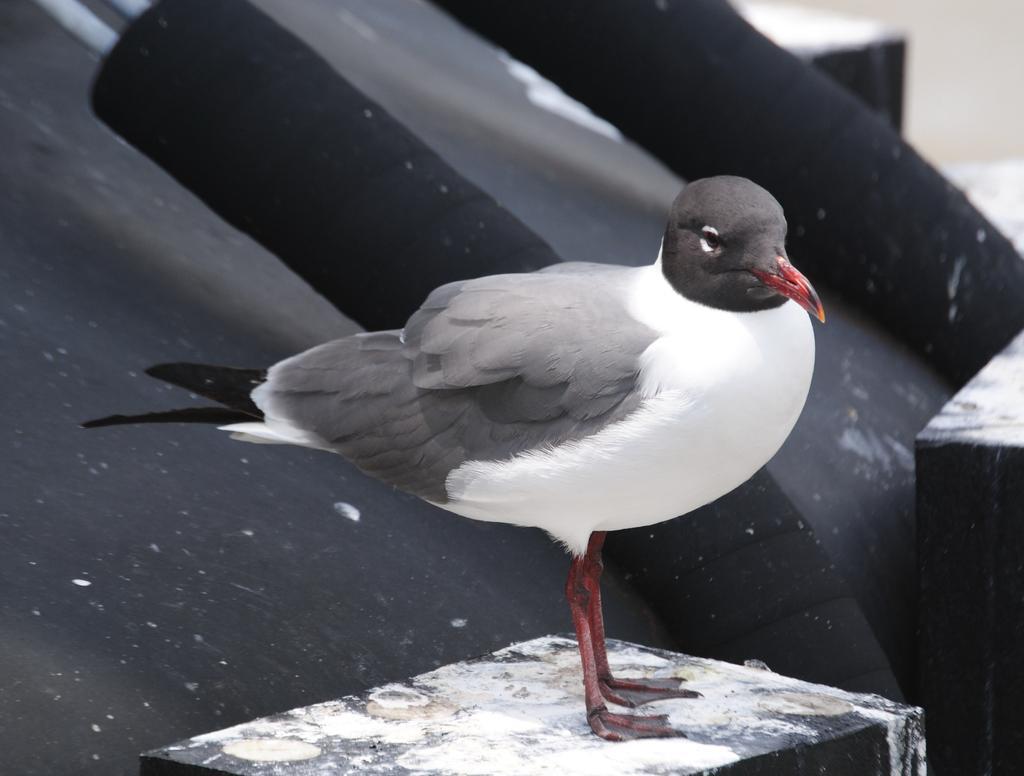Can you describe this image briefly? There is a white, gray and black color bird with red beak and legs. It is standing on a stand. In the back it is black in color. 